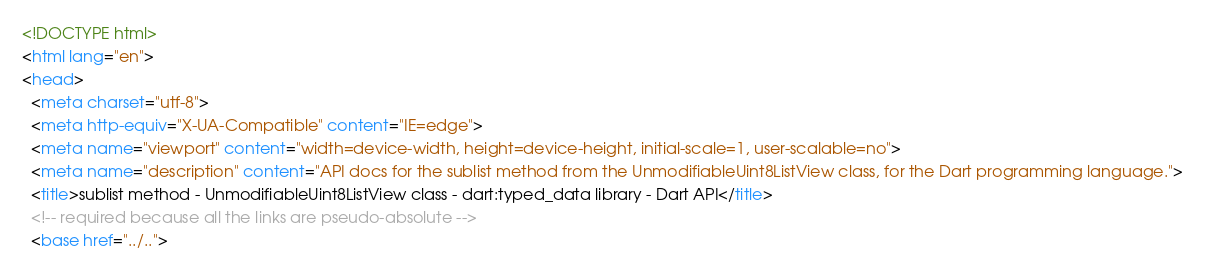<code> <loc_0><loc_0><loc_500><loc_500><_HTML_><!DOCTYPE html>
<html lang="en">
<head>
  <meta charset="utf-8">
  <meta http-equiv="X-UA-Compatible" content="IE=edge">
  <meta name="viewport" content="width=device-width, height=device-height, initial-scale=1, user-scalable=no">
  <meta name="description" content="API docs for the sublist method from the UnmodifiableUint8ListView class, for the Dart programming language.">
  <title>sublist method - UnmodifiableUint8ListView class - dart:typed_data library - Dart API</title>
  <!-- required because all the links are pseudo-absolute -->
  <base href="../..">
</code> 